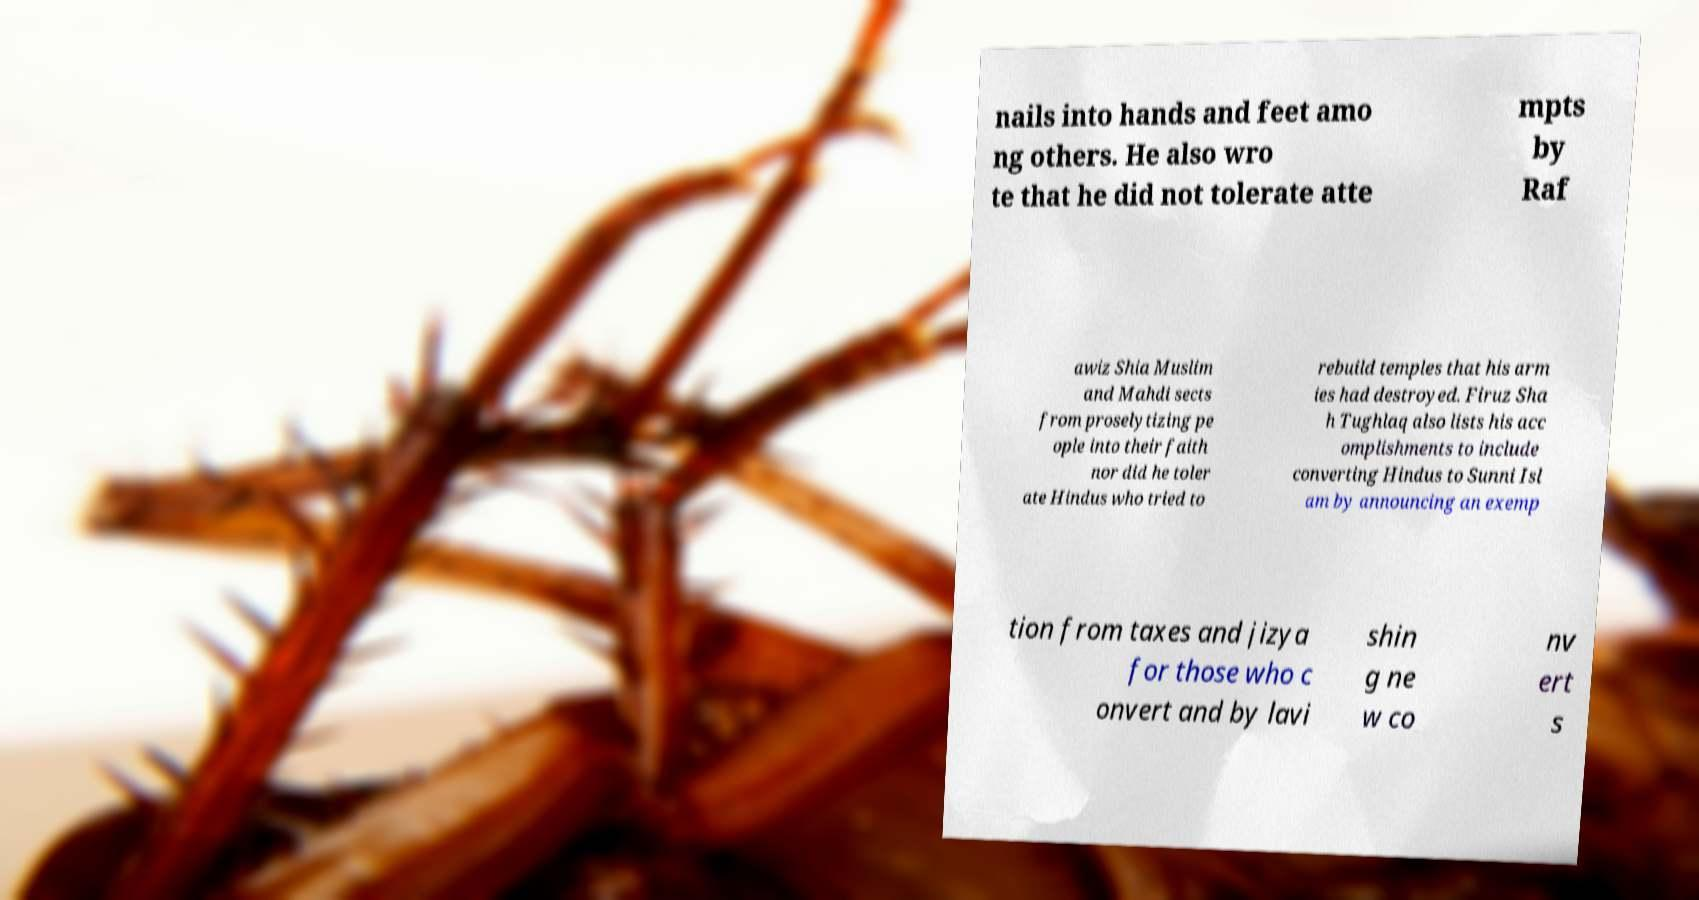There's text embedded in this image that I need extracted. Can you transcribe it verbatim? nails into hands and feet amo ng others. He also wro te that he did not tolerate atte mpts by Raf awiz Shia Muslim and Mahdi sects from proselytizing pe ople into their faith nor did he toler ate Hindus who tried to rebuild temples that his arm ies had destroyed. Firuz Sha h Tughlaq also lists his acc omplishments to include converting Hindus to Sunni Isl am by announcing an exemp tion from taxes and jizya for those who c onvert and by lavi shin g ne w co nv ert s 